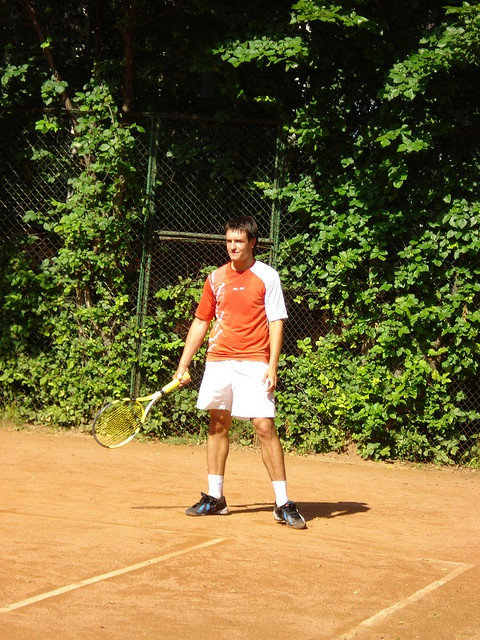Describe the objects in this image and their specific colors. I can see people in black, white, orange, tan, and red tones and tennis racket in black, olive, khaki, and ivory tones in this image. 